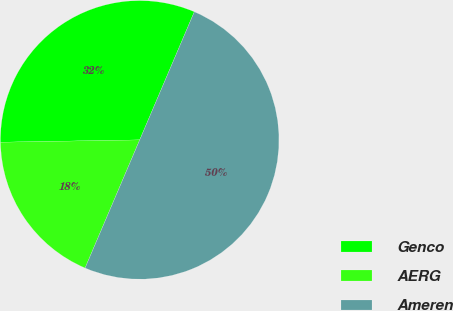<chart> <loc_0><loc_0><loc_500><loc_500><pie_chart><fcel>Genco<fcel>AERG<fcel>Ameren<nl><fcel>31.68%<fcel>18.32%<fcel>50.0%<nl></chart> 